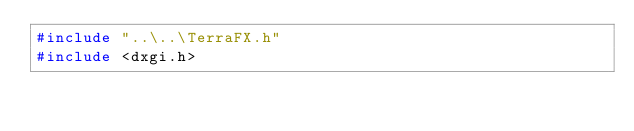Convert code to text. <code><loc_0><loc_0><loc_500><loc_500><_C_>#include "..\..\TerraFX.h"
#include <dxgi.h>
</code> 